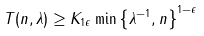<formula> <loc_0><loc_0><loc_500><loc_500>T ( n , \lambda ) \geq K _ { 1 \epsilon } \min \left \{ \lambda ^ { - 1 } , n \right \} ^ { 1 - \epsilon }</formula> 